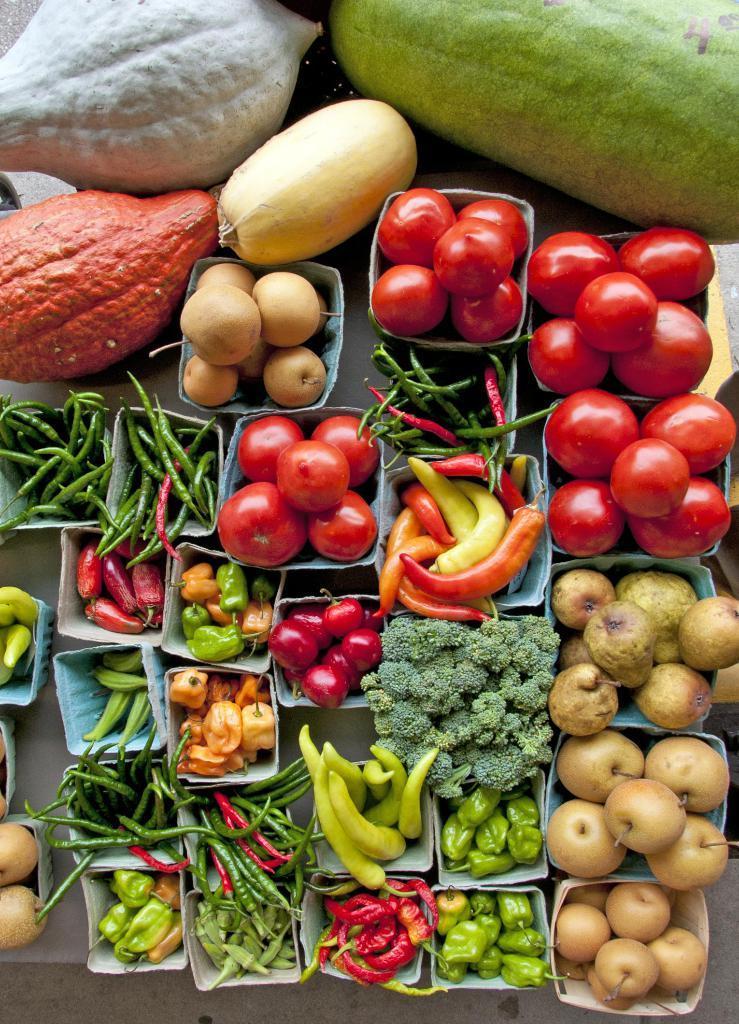Describe this image in one or two sentences. In this image there are vegetables in the boxes, there are boxes on a table, there are vegetables truncated towards the top of the image, there are vegetables truncated towards the left of the image, there is a table truncated towards the left of the image. 